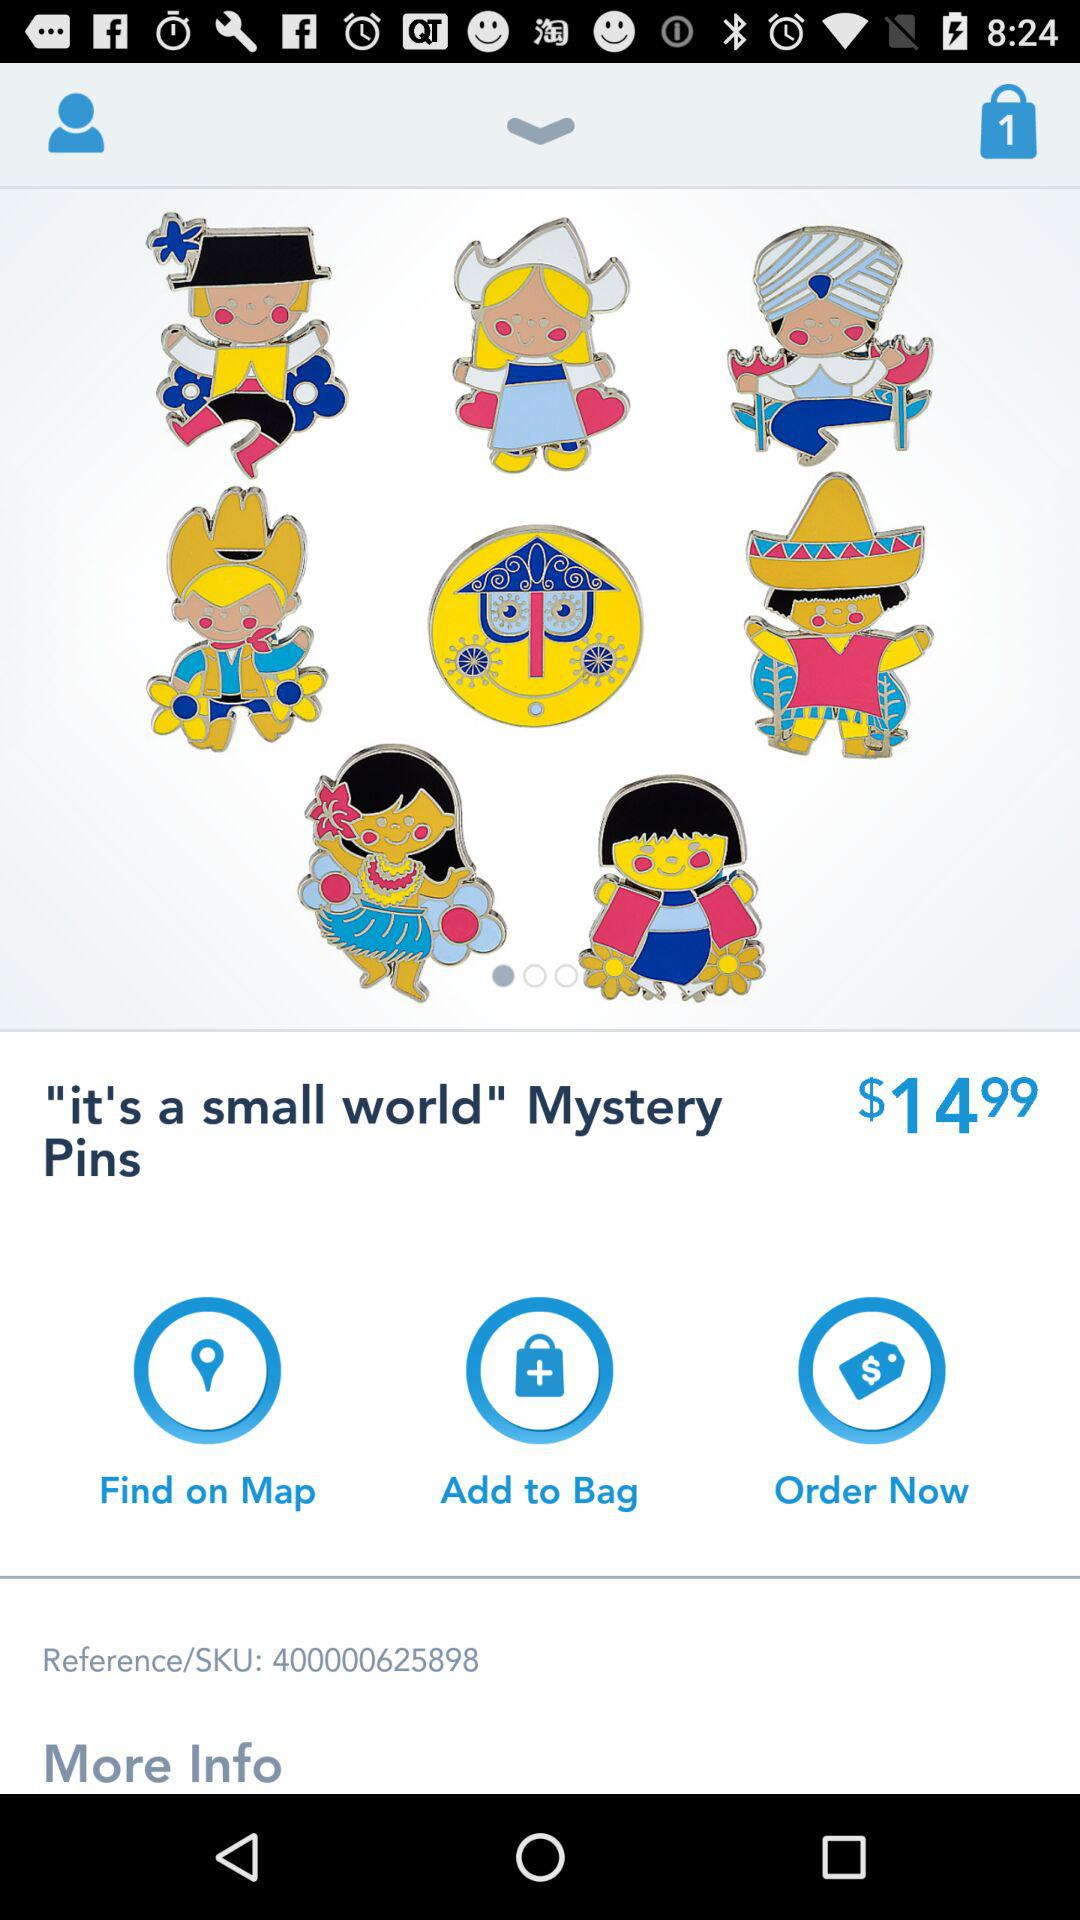What is the price? The price is $14.99. 